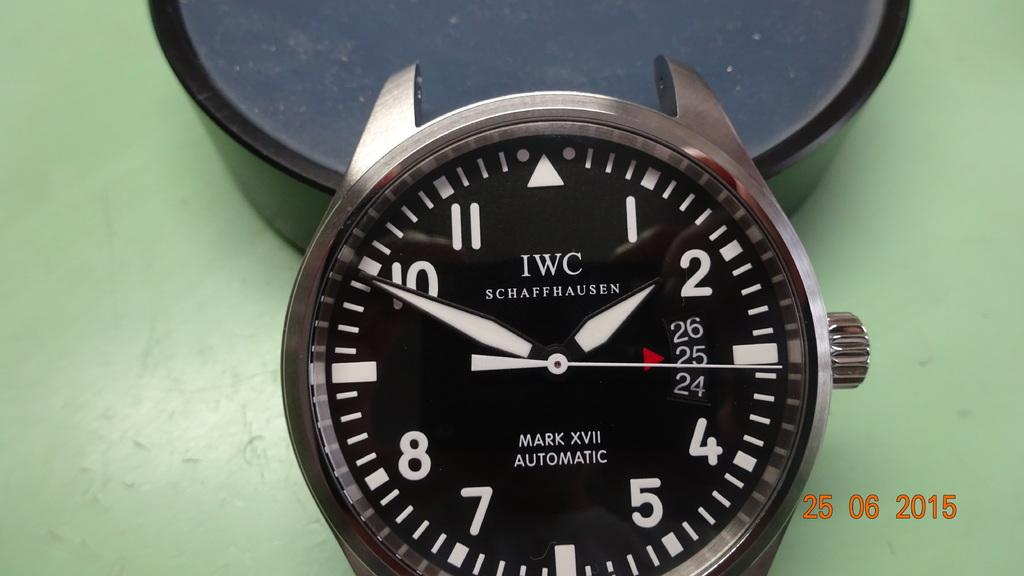<image>
Offer a succinct explanation of the picture presented. A picture of a clock that was taken on August 25, 2015. 